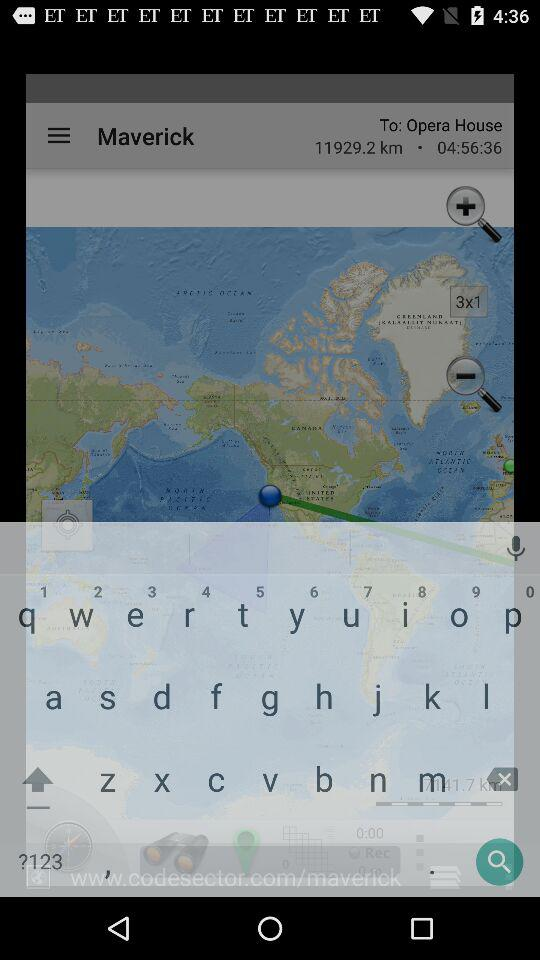What is the given time? The given time is 04:56:36. 